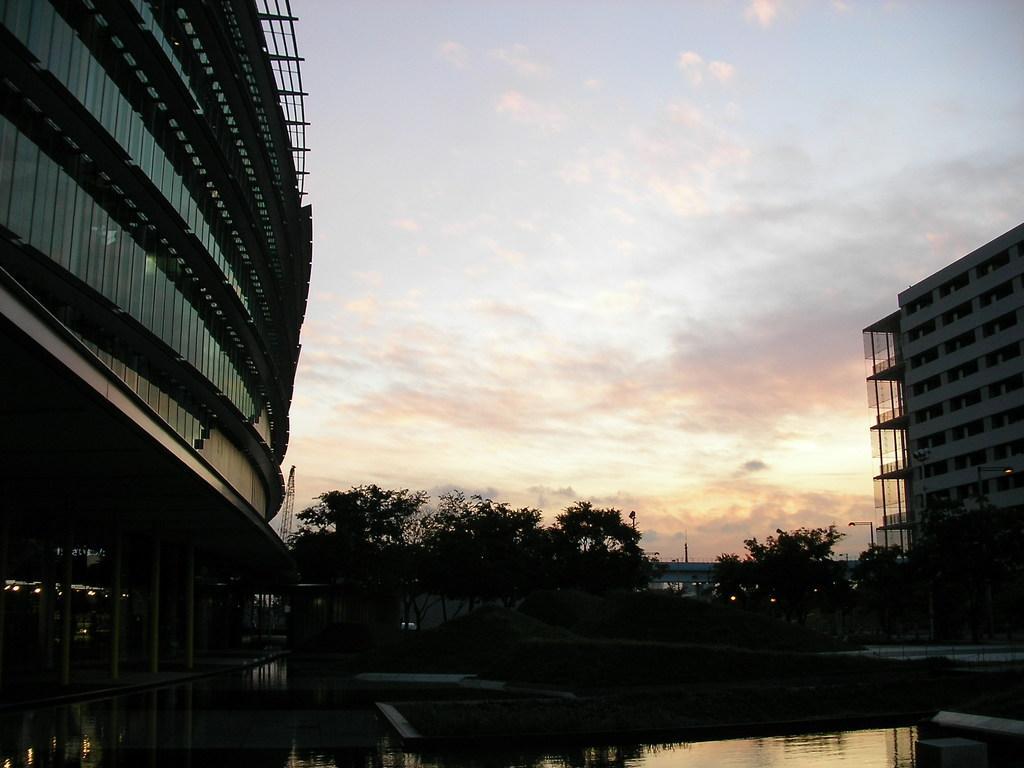Please provide a concise description of this image. In the foreground of the picture there is water. In the center of the picture there are trees, lights, towers, streetlight and buildings. Sky is bit cloudy. This is a picture during sunset. 